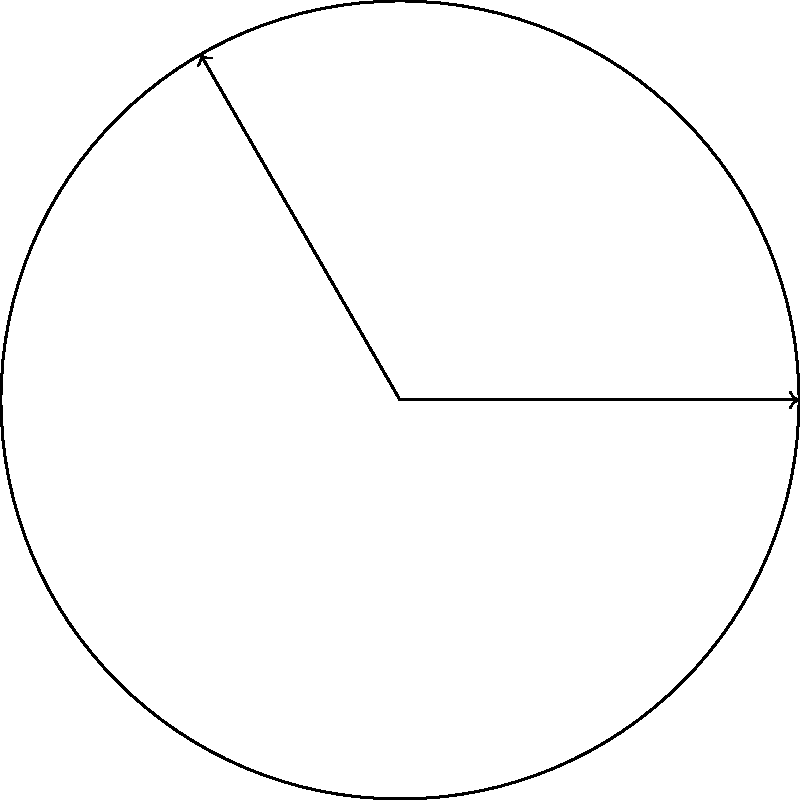In a classic kaiju film, a crucial scene is stored on a circular film reel with a radius of 15 cm. If the scene occupies a 120° arc on the reel, what is the length of the film containing this scene? To solve this problem, we'll use the formula for arc length:

$s = r\theta$

Where:
$s$ = arc length
$r$ = radius of the circle
$\theta$ = central angle in radians

Step 1: Convert the angle from degrees to radians.
$\theta = 120° \times \frac{\pi}{180°} = \frac{2\pi}{3}$ radians

Step 2: Apply the arc length formula.
$s = r\theta$
$s = 15 \times \frac{2\pi}{3}$
$s = 10\pi$ cm

Step 3: Simplify if needed (in this case, we'll leave it as $10\pi$ cm).

This length represents the portion of the film containing the crucial kaiju scene on the reel.
Answer: $10\pi$ cm 